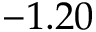<formula> <loc_0><loc_0><loc_500><loc_500>- 1 . 2 0</formula> 